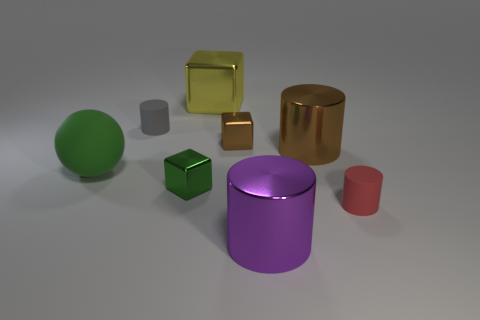Add 1 tiny gray matte cylinders. How many objects exist? 9 Subtract all cubes. How many objects are left? 5 Subtract all purple metallic things. Subtract all gray things. How many objects are left? 6 Add 6 large metal cubes. How many large metal cubes are left? 7 Add 5 brown shiny cubes. How many brown shiny cubes exist? 6 Subtract 0 cyan balls. How many objects are left? 8 